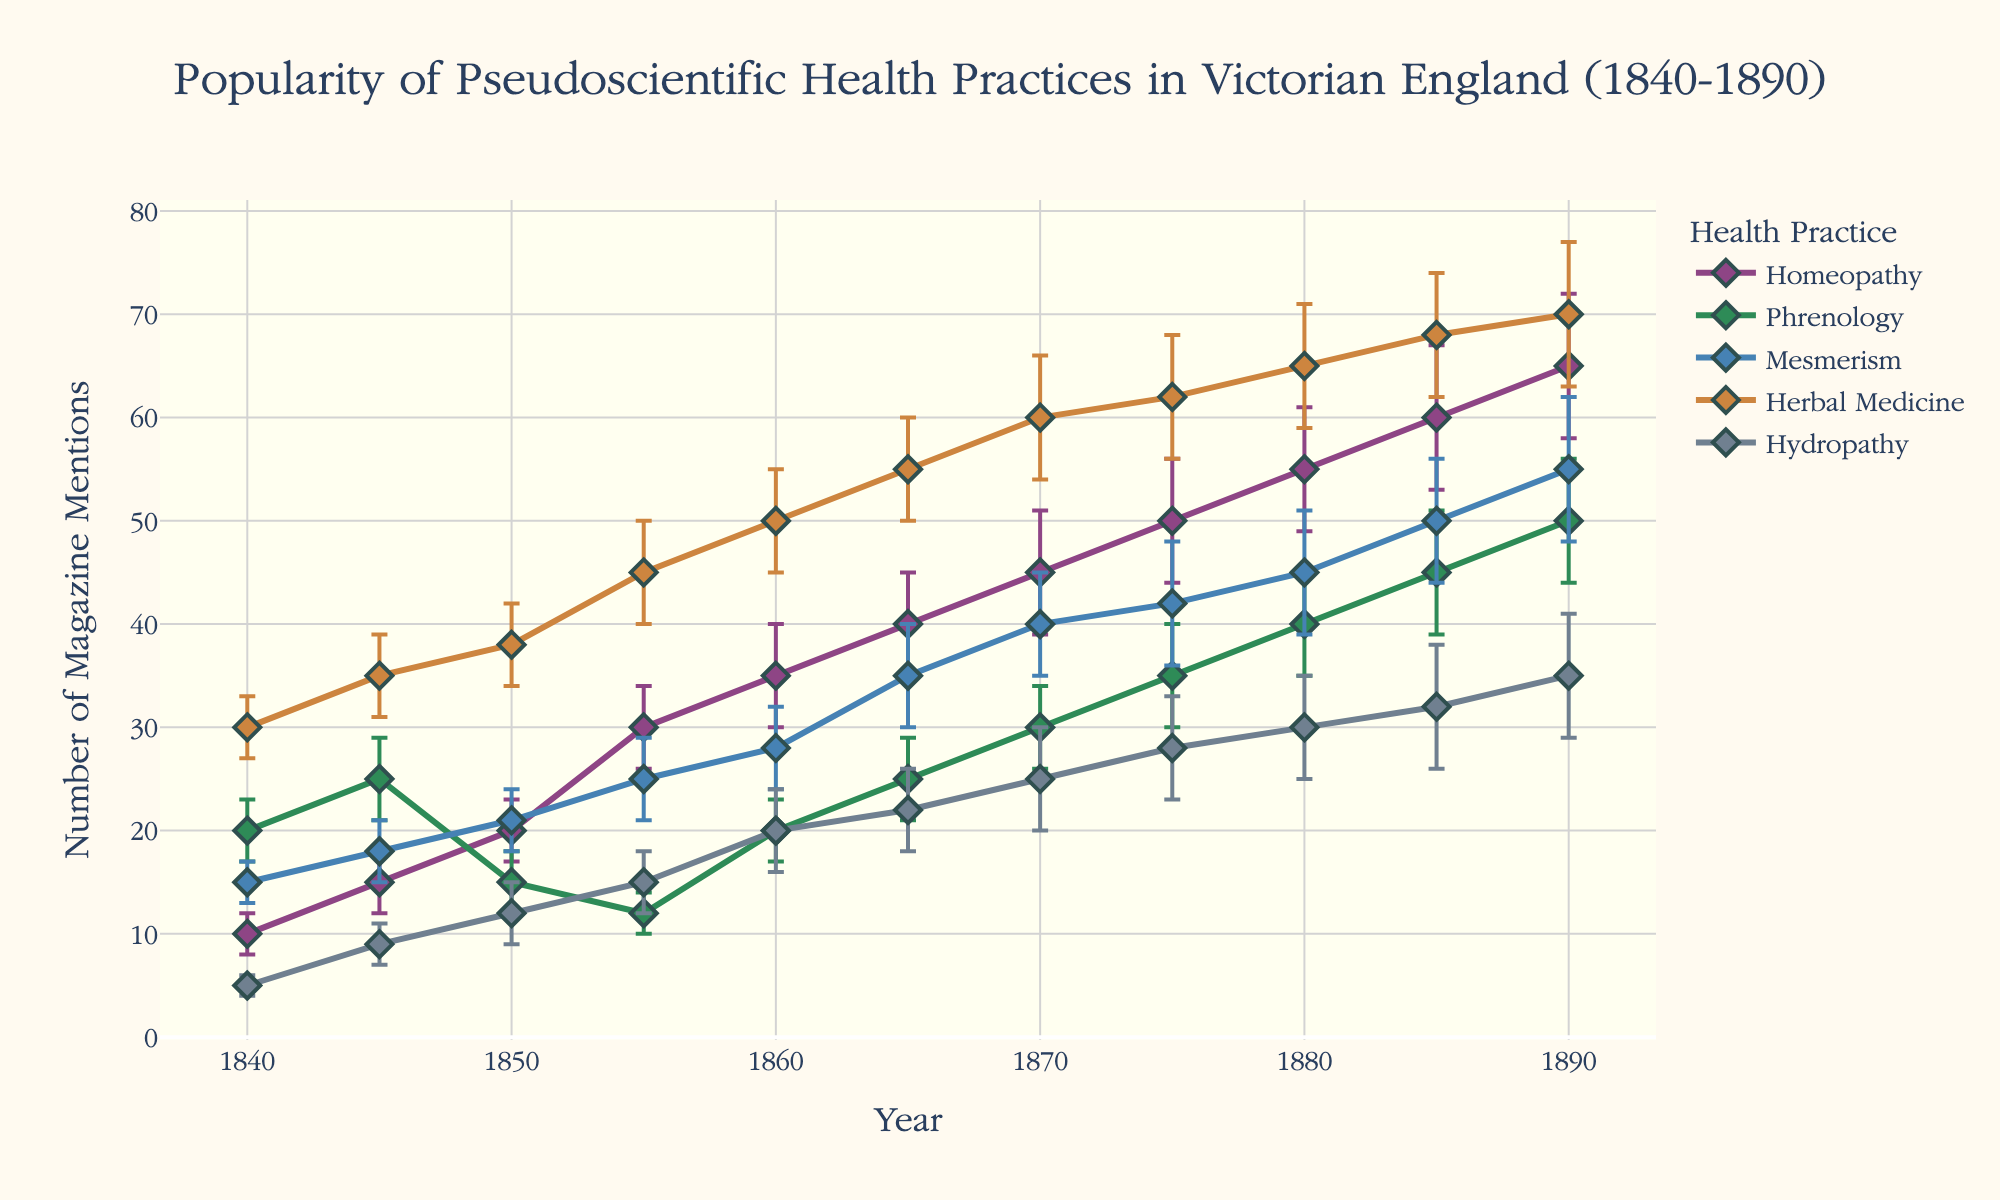what is the title of the figure? The title of the figure is prominently displayed at the top, indicating the main subject of the visualization.
Answer: Popularity of Pseudoscientific Health Practices in Victorian England (1840-1890) what do the y-axis and x-axis represent? The y-axis represents the number of magazine mentions, and the x-axis represents the years from 1840 to 1890.
Answer: y-axis: Number of Magazine Mentions, x-axis: Year how many health practices are being compared in the figure? By observing the legend and the lines on the figure, we can see that there are five health practices being compared.
Answer: 5 which health practice had the highest number of mentions in 1890? By tracing the lines to the year 1890 on the x-axis and observing the values, we see that Homeopathy had the highest number of mentions.
Answer: Homeopathy what is the trend of Herbal Medicine mentions from 1840 to 1890? By examining the line representing Herbal Medicine, we notice a steady increase in the number of mentions from 30 in 1840 to 70 in 1890.
Answer: Increasing how do the error bars for Homeopathy in 1855 compare to those in 1880? By observing the error bars for Homeopathy at these two points, we can see that the error bars are larger in 1880 compared to 1855.
Answer: Larger in 1880 which health practice shows a significant increase in mentions between 1840 and 1860? By analyzing the slopes of the lines, we observe that Homeopathy shows a significant increase in mentions between these two years, rising from 10 to 35 mentions.
Answer: Homeopathy what is the overall trend for Phrenology from 1840 to 1890? By following the Phrenology line, we see that it has some fluctuations but does not show a clear increasing or decreasing trend.
Answer: Fluctuating in which year did Mesmerism have the highest number of mentions, and what was that number? By tracing the Mesmerism line, we identify that the highest number of mentions was in 1890, with a total of 55.
Answer: 1890, 55 compare the mentions of Hydropathy in 1840 and 1890. What is the difference? The mentions of Hydropathy were 5 in 1840 and 35 in 1890. The difference is calculated as 35 - 5.
Answer: 30 